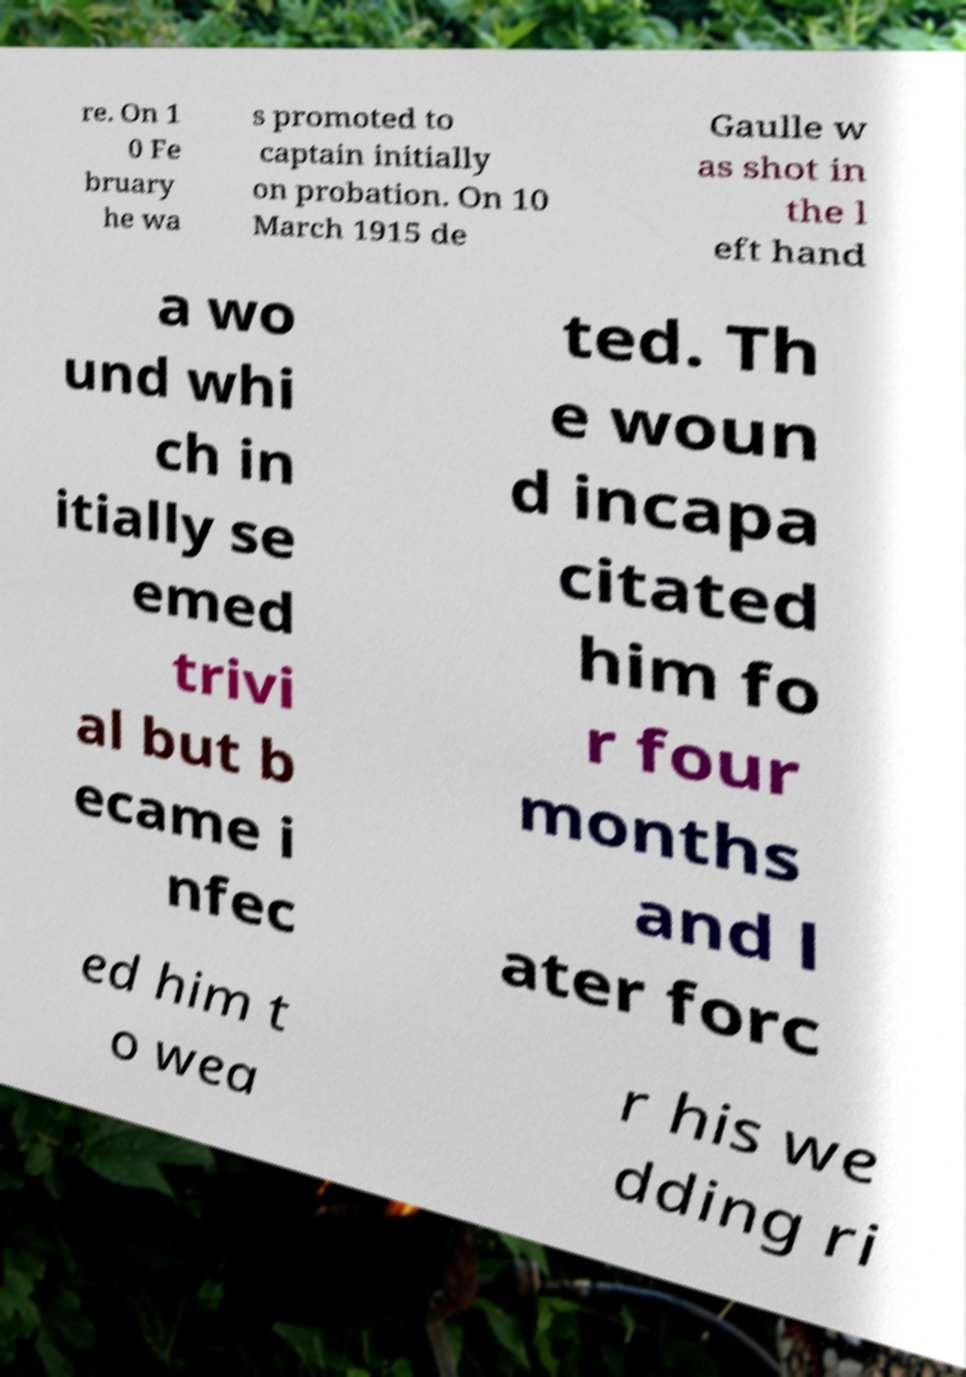I need the written content from this picture converted into text. Can you do that? re. On 1 0 Fe bruary he wa s promoted to captain initially on probation. On 10 March 1915 de Gaulle w as shot in the l eft hand a wo und whi ch in itially se emed trivi al but b ecame i nfec ted. Th e woun d incapa citated him fo r four months and l ater forc ed him t o wea r his we dding ri 